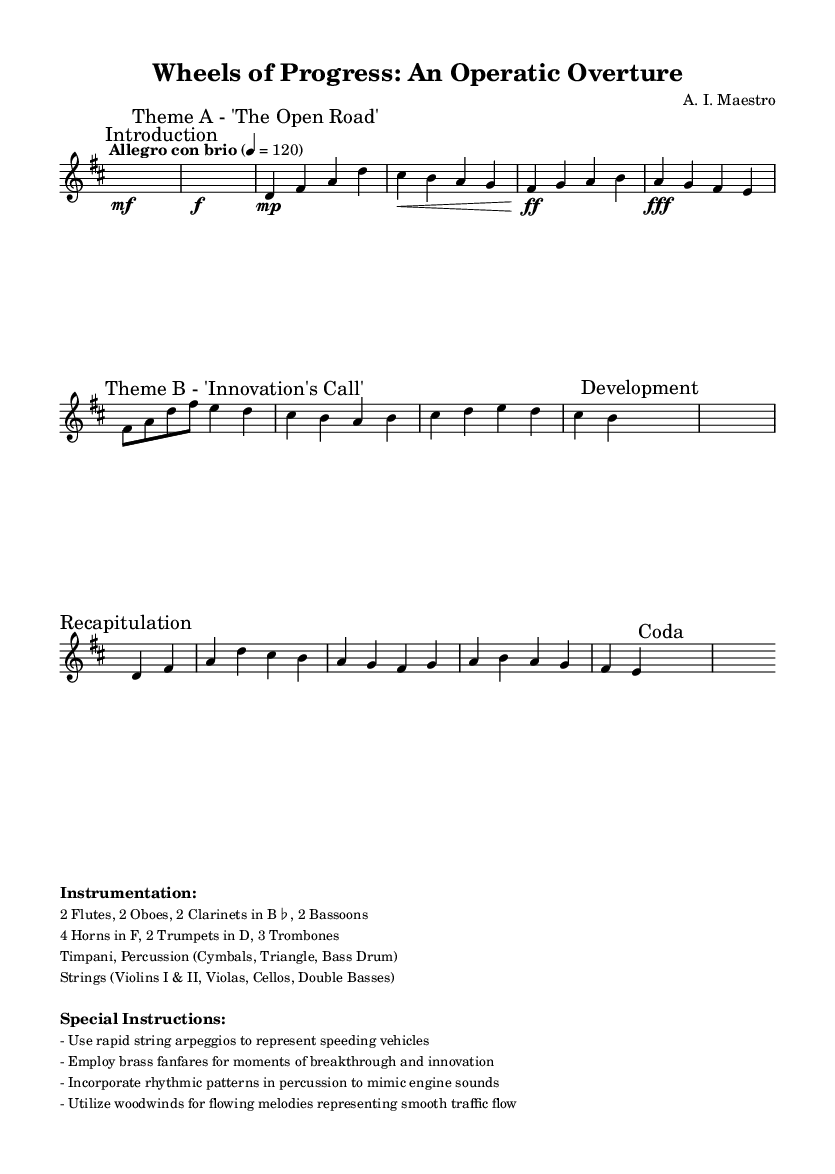What is the key signature of this music? The key signature is indicated at the beginning of the score. It shows two sharp symbols, signifying that the piece is in D major.
Answer: D major What is the time signature of this music? The time signature is found at the start of the score, showing a "4/4" indication, which means there are four beats in each measure.
Answer: 4/4 What is the tempo marking for this piece? The tempo is indicated in Italian commonly used in classical music. Here it is marked as "Allegro con brio," which implies a lively tempo.
Answer: Allegro con brio How many horns are included in the instrumentation? The instrumentation section lists the instruments included in the score. It specifies "4 Horns in F," indicating a total of four horns.
Answer: 4 What thematic material represents the idea of 'progress' in this overture? The overture includes sections that are marked as themes. The theme "The Open Road" signifies the concept of progress, reflecting on movement and forward motion.
Answer: The Open Road What role do the brass instruments play in the overture? In the special instructions, it states that brass fanfares are to be used for moments of breakthrough and innovation, indicating their role in highlighting significant sections.
Answer: Breakthrough and innovation 